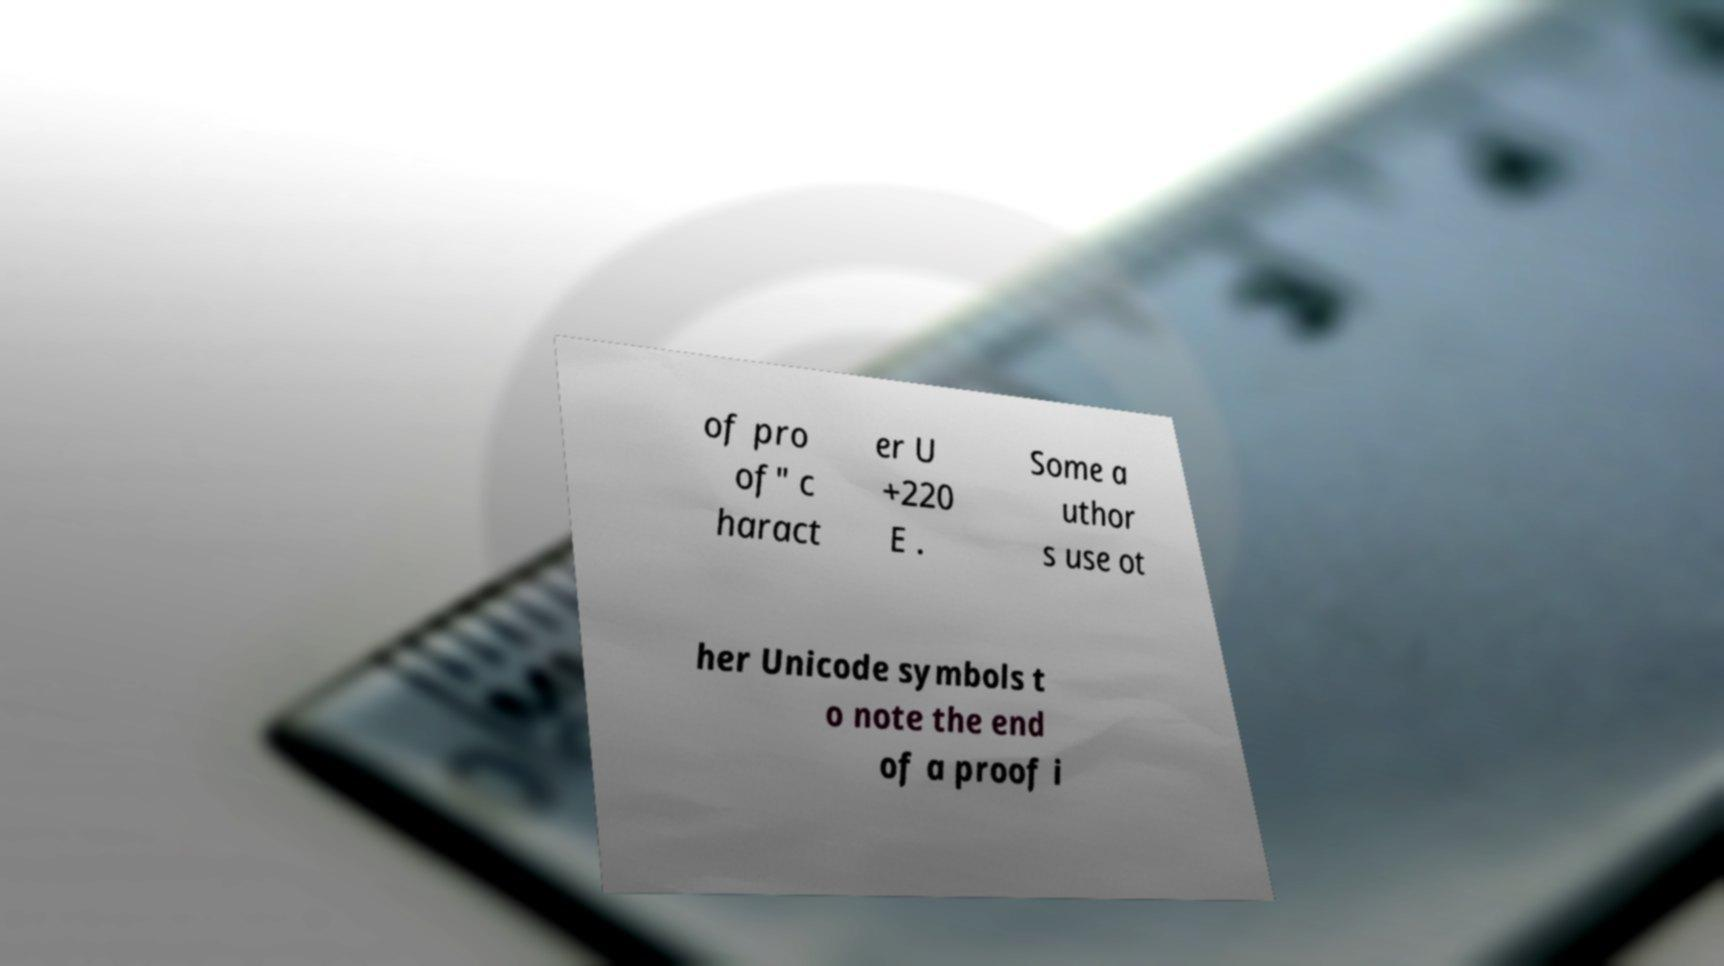Please identify and transcribe the text found in this image. of pro of" c haract er U +220 E . Some a uthor s use ot her Unicode symbols t o note the end of a proof i 